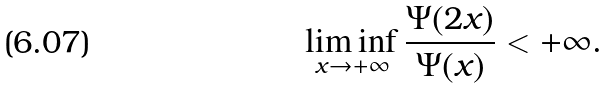<formula> <loc_0><loc_0><loc_500><loc_500>\liminf _ { x \to + \infty } \frac { \Psi ( 2 x ) } { \Psi ( x ) } < + \infty .</formula> 